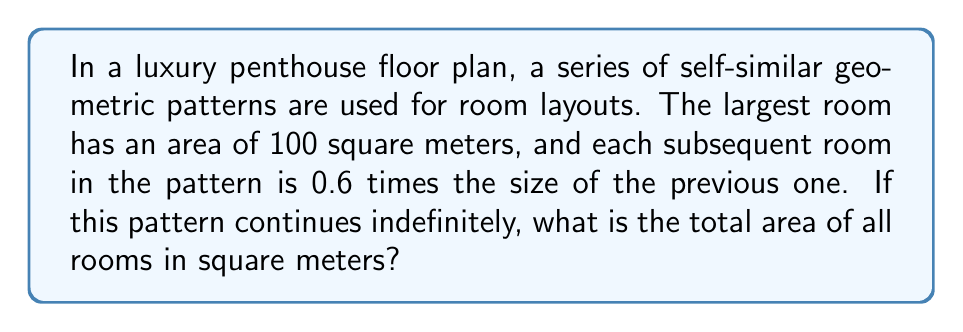Help me with this question. To solve this problem, we need to recognize that this is an example of a geometric series with a fractal pattern. Let's approach this step-by-step:

1) The areas of the rooms form a geometric sequence with:
   - First term: $a = 100$ (the area of the largest room)
   - Common ratio: $r = 0.6$ (each room is 0.6 times the size of the previous one)

2) The sum of an infinite geometric series is given by the formula:
   
   $S_{\infty} = \frac{a}{1-r}$, where $|r| < 1$

3) In this case:
   $a = 100$
   $r = 0.6$
   $|r| = 0.6 < 1$, so we can use the formula

4) Substituting these values:

   $S_{\infty} = \frac{100}{1-0.6}$

5) Simplifying:
   
   $S_{\infty} = \frac{100}{0.4} = 250$

Therefore, the total area of all rooms in this infinite fractal pattern is 250 square meters.
Answer: 250 square meters 